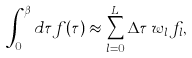Convert formula to latex. <formula><loc_0><loc_0><loc_500><loc_500>\int _ { 0 } ^ { \beta } d \tau f ( \tau ) \approx \sum _ { l = 0 } ^ { L } \Delta \tau \, w _ { l } \, f _ { l } ,</formula> 